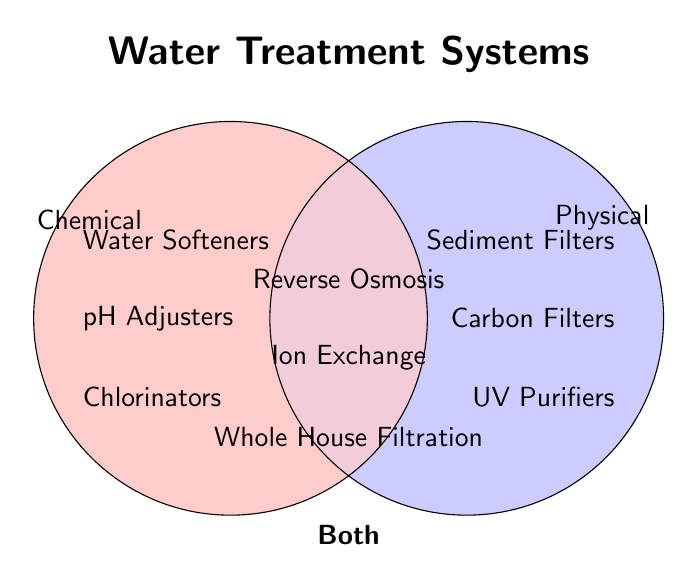What are examples of chemical water treatment? The chemical treatments are listed in the red (left) section of the Venn diagram.
Answer: Water Softeners, pH Adjusters, Chlorinators Which types of water treatment systems fall under both categories? The treatments in the overlapping purple section are in both categories.
Answer: Reverse Osmosis, Ion Exchange, Whole House Filtration How many types of physical water treatments are shown? The physical treatments are listed in the blue (right) section of the Venn diagram. Count them.
Answer: 3 Which category has more treatment types, chemical or both? Count the treatment types in each category and compare. Chemical has 3; both have 3. They are equal.
Answer: Both (by count) Are UV Purifiers classified under both categories? Check if UV Purifiers are in the overlapping section (purple) of the Venn diagram. They aren't; they are entirely in the blue section.
Answer: No Is Reverse Osmosis a chemical water treatment? Verify if Reverse Osmosis appears in the red (left) section. It doesn't; it is in both.
Answer: No What treatment type would you use if you wanted both chemical and physical properties? Look at the overlapping section to find treatments with both properties.
Answer: Reverse Osmosis, Ion Exchange, Whole House Filtration List all treatment types that aren't classified as purely chemical. Combine the types under physical (Sediment Filters, Carbon Filters, UV Purifiers) and both categories (Reverse Osmosis, Ion Exchange, Whole House Filtration).
Answer: Sediment Filters, Carbon Filters, UV Purifiers, Reverse Osmosis, Ion Exchange, Whole House Filtration 